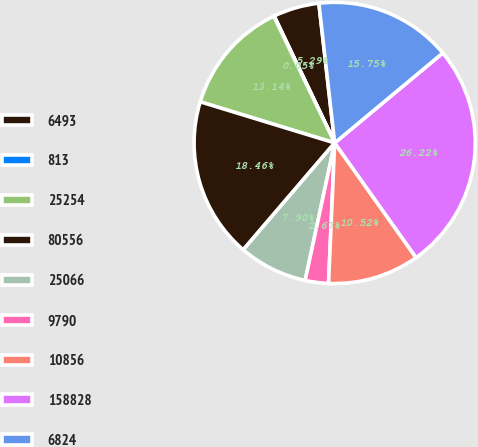<chart> <loc_0><loc_0><loc_500><loc_500><pie_chart><fcel>6493<fcel>813<fcel>25254<fcel>80556<fcel>25066<fcel>9790<fcel>10856<fcel>158828<fcel>6824<nl><fcel>5.29%<fcel>0.05%<fcel>13.14%<fcel>18.46%<fcel>7.9%<fcel>2.67%<fcel>10.52%<fcel>26.22%<fcel>15.75%<nl></chart> 